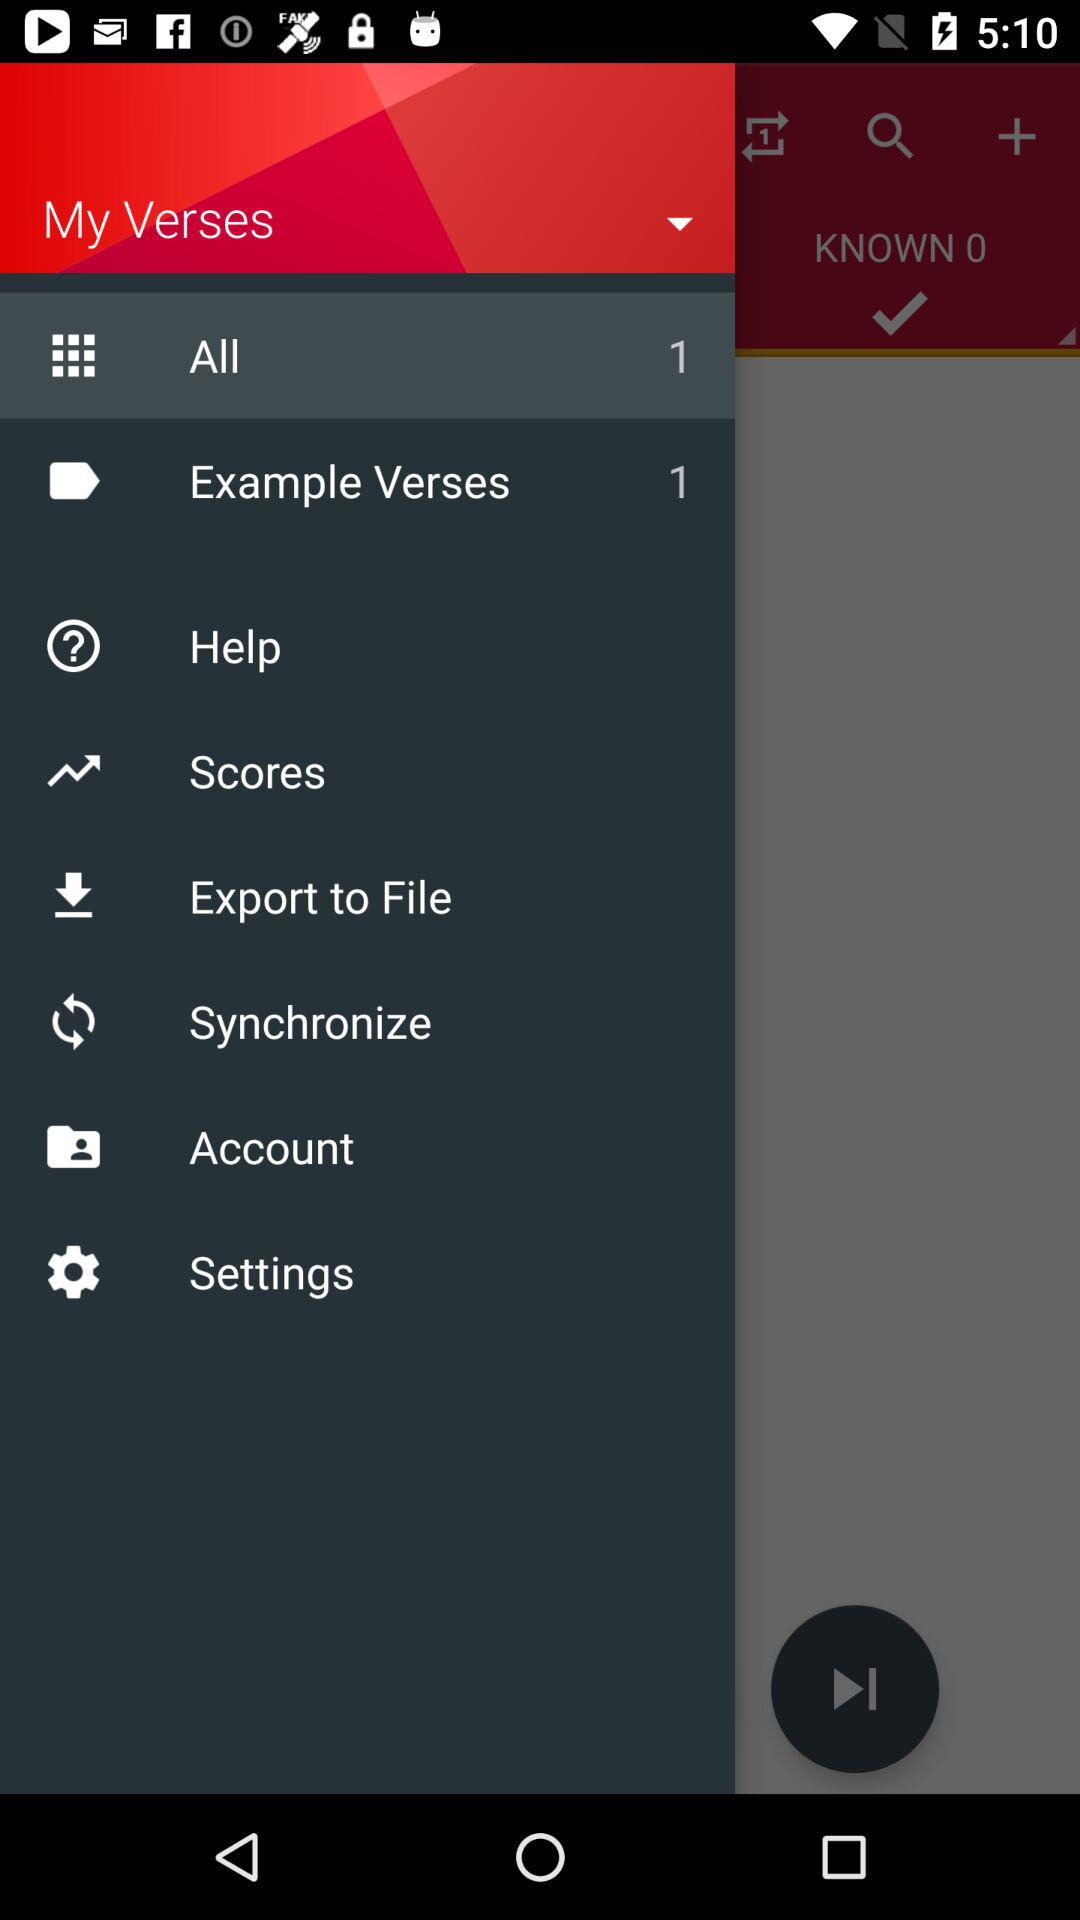How many items are there in the "All" category? There is 1 item in the "All" category. 